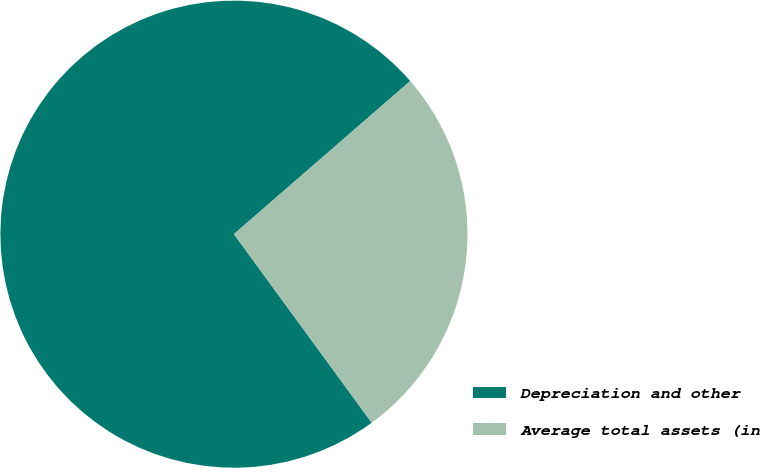<chart> <loc_0><loc_0><loc_500><loc_500><pie_chart><fcel>Depreciation and other<fcel>Average total assets (in<nl><fcel>73.66%<fcel>26.34%<nl></chart> 